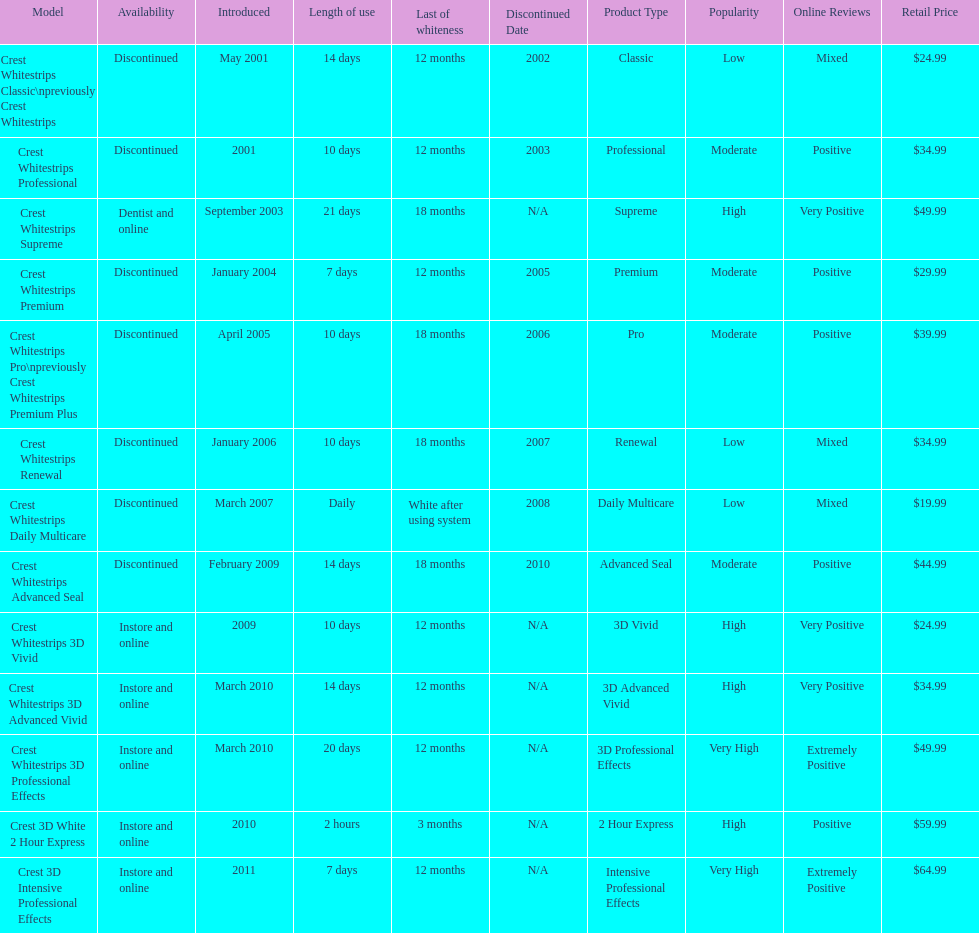What product was introduced in the same month as crest whitestrips 3d advanced vivid? Crest Whitestrips 3D Professional Effects. 